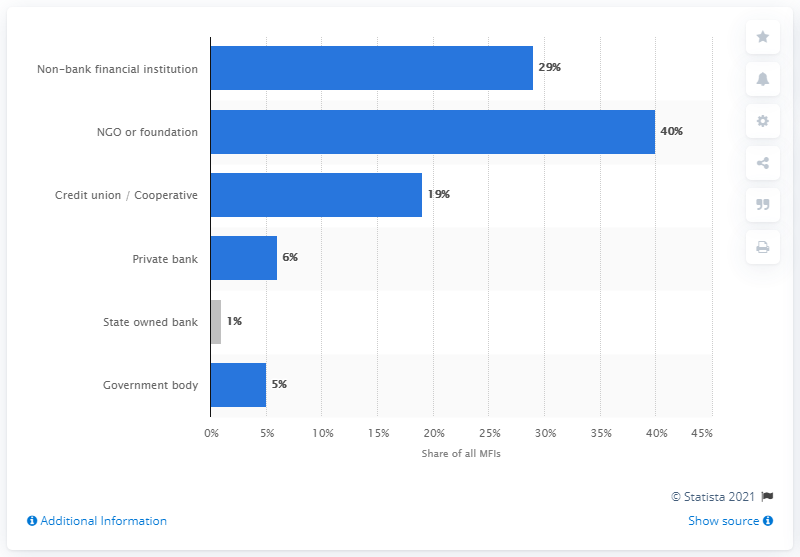Mention a couple of crucial points in this snapshot. In 2017, Non-Governmental Organizations (NGOs) and foundations were the most common forms of Microfinance Institutions (MFIs). A significant percentage of institutions in Europe are currently providing microloans. 